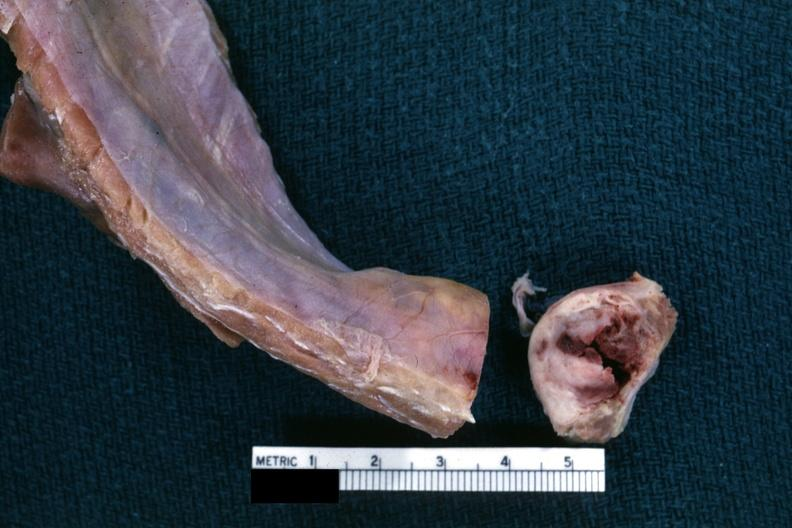what sectioned to show white neoplasm with central hemorrhage?
Answer the question using a single word or phrase. Lesion cross 